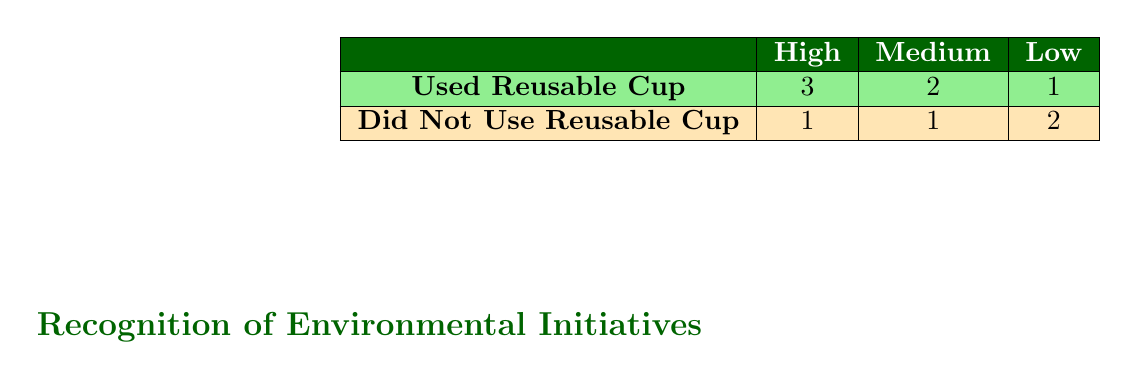What is the total number of coffee shops that recognized environmental initiatives as 'High'? From the table, we see that the row for 'Used Reusable Cup' under 'High' has a value of 3, indicating that three coffee shops recognized initiatives at a high level.
Answer: 3 How many coffee shops that did not use a reusable cup recognized initiatives as 'Medium'? The row for 'Did Not Use Reusable Cup' under 'Medium' shows a value of 1, meaning there is one coffee shop that recognized initiatives at a medium level without using a reusable cup.
Answer: 1 Which recognition level has the highest number of coffee shops that used reusable cups? Looking at the 'Used Reusable Cup' row, the 'High' recognition has 3 coffee shops, which is the highest compared to the other recognition levels.
Answer: High Is it true that there are more coffee shops recognizing initiatives at 'Low' compared to those that used reusable cups? Checking the 'Low' column, we see 1 coffee shop used a reusable cup and 2 did not. Since 2 is greater than 1, the statement is true.
Answer: Yes What is the difference in the number of coffee shops recognizing initiatives at 'High' and 'Low' that have used a reusable cup? The 'High' category has 3 coffee shops and the 'Low' category has 1 coffee shop. The difference is 3 - 1 = 2.
Answer: 2 How many coffee shops did not use reusable cups in total? Looking at both the 'Low' (2) and 'Medium' (1) rows under 'Did Not Use Reusable Cup,' we add these values to get a total of 2 + 1 = 3 coffee shops that did not use reusable cups.
Answer: 3 Find the average number of coffee shops that recognized initiatives at 'Medium' across both categories of reusable cup usage. The 'Medium' category had 2 coffee shops using reusable cups and 1 not using them. The total number is 2 + 1 = 3, and average = 3 / 2 = 1.5.
Answer: 1.5 How many coffee shops recognized initiatives at 'High' and did not use a reusable cup? Referring to the 'Did Not Use Reusable Cup' row under 'High,' it indicates that there is 1 coffee shop.
Answer: 1 